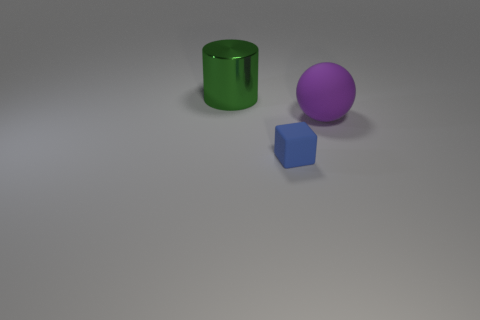Add 3 big red cubes. How many objects exist? 6 Subtract all cylinders. How many objects are left? 2 Subtract all cylinders. Subtract all cylinders. How many objects are left? 1 Add 2 large purple things. How many large purple things are left? 3 Add 2 tiny blue matte things. How many tiny blue matte things exist? 3 Subtract 0 gray cylinders. How many objects are left? 3 Subtract 1 balls. How many balls are left? 0 Subtract all blue cylinders. Subtract all gray spheres. How many cylinders are left? 1 